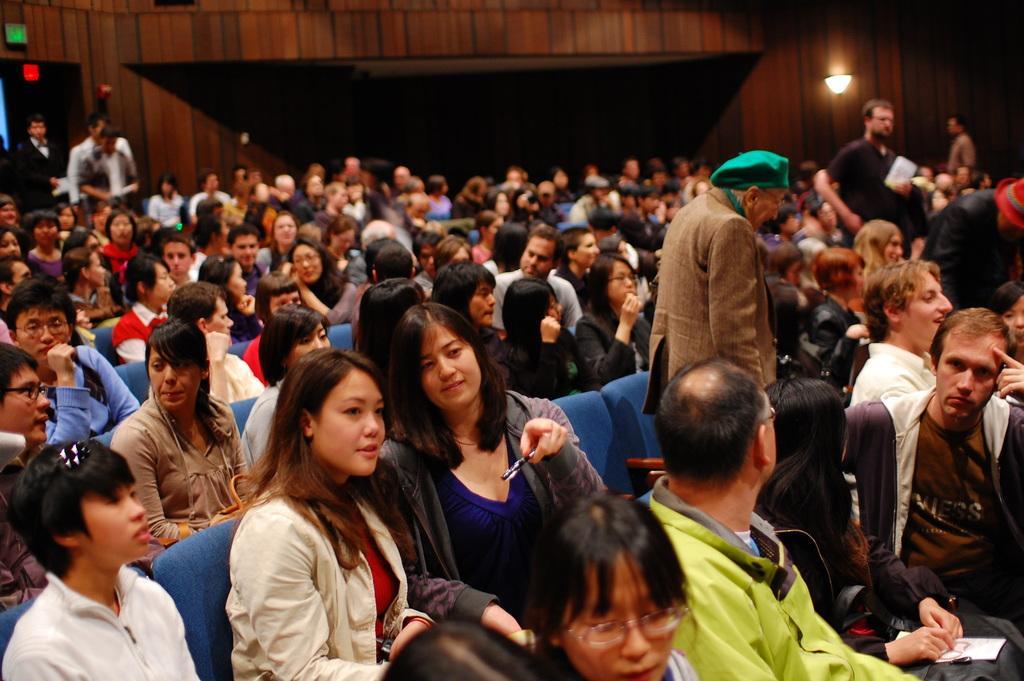Describe this image in one or two sentences. In this image I can see the group of people sitting on the chairs and few people are standing. I can see these people are wearing the different color dresses. In the background I can see the light and the boards to the brown color wall. 